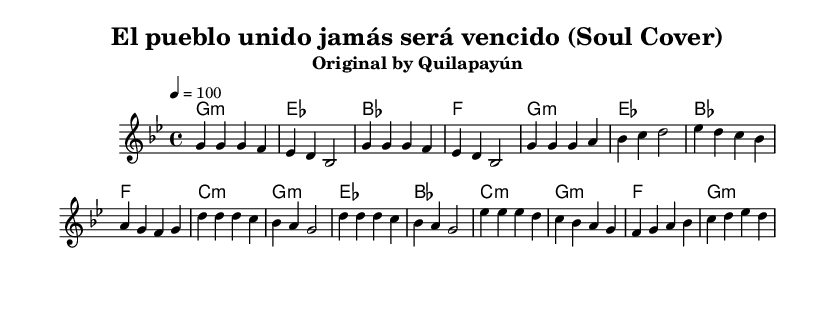What is the key signature of this music? The key signature is indicated at the beginning of the sheet music. It shows two flats on the staff, identifying it as G minor.
Answer: G minor What is the time signature of the piece? The time signature is shown in the first measure of the sheet music, indicated by the numbers 4 over 4. This signifies a common time, meaning there are four beats per measure.
Answer: 4/4 What is the tempo indicated for this music? The tempo is found at the top of the score, notated as "4 = 100," which indicates a speed of 100 beats per minute.
Answer: 100 How many measures are in the verse section? By counting the number of distinct melodic phrases from the start to the end of the verse, there are a total of 8 measures.
Answer: 8 What is the chord progression used in the chorus? The chord progression can be deduced from the chords written alongside the melody. The sequence is D, B flat, A, G, and F.
Answer: D, B flat, A, G, F What type of musical form is likely used in this piece? Given that the sheet music contains repetitive verses and a contrasting chorus, it suggests a verse-chorus form common in soul music as well as other genres.
Answer: Verse-chorus What is the style adaptation of the original song? The title notes "Soul Cover," indicating this piece is a reinterpretation of the original protest song by Quilapayún, infused with elements typical of soul music.
Answer: Soul 